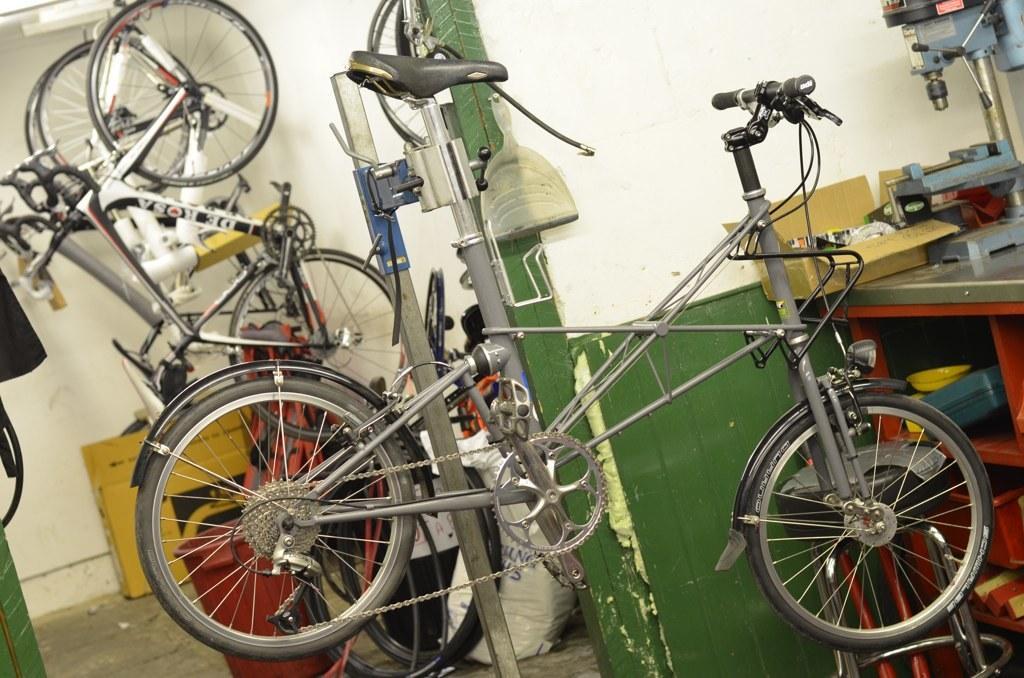Describe this image in one or two sentences. In this picture, we see many bicycles. On the right side, we see a table on which a box and machinery equipment are placed. Beside that, we see a green wall. Behind that, we see a plastic bag and a garbage bin in red color. In the background, we see a yellow table. In the background, we see a wall which is white in color. This picture might be clicked in the bicycle garage. 